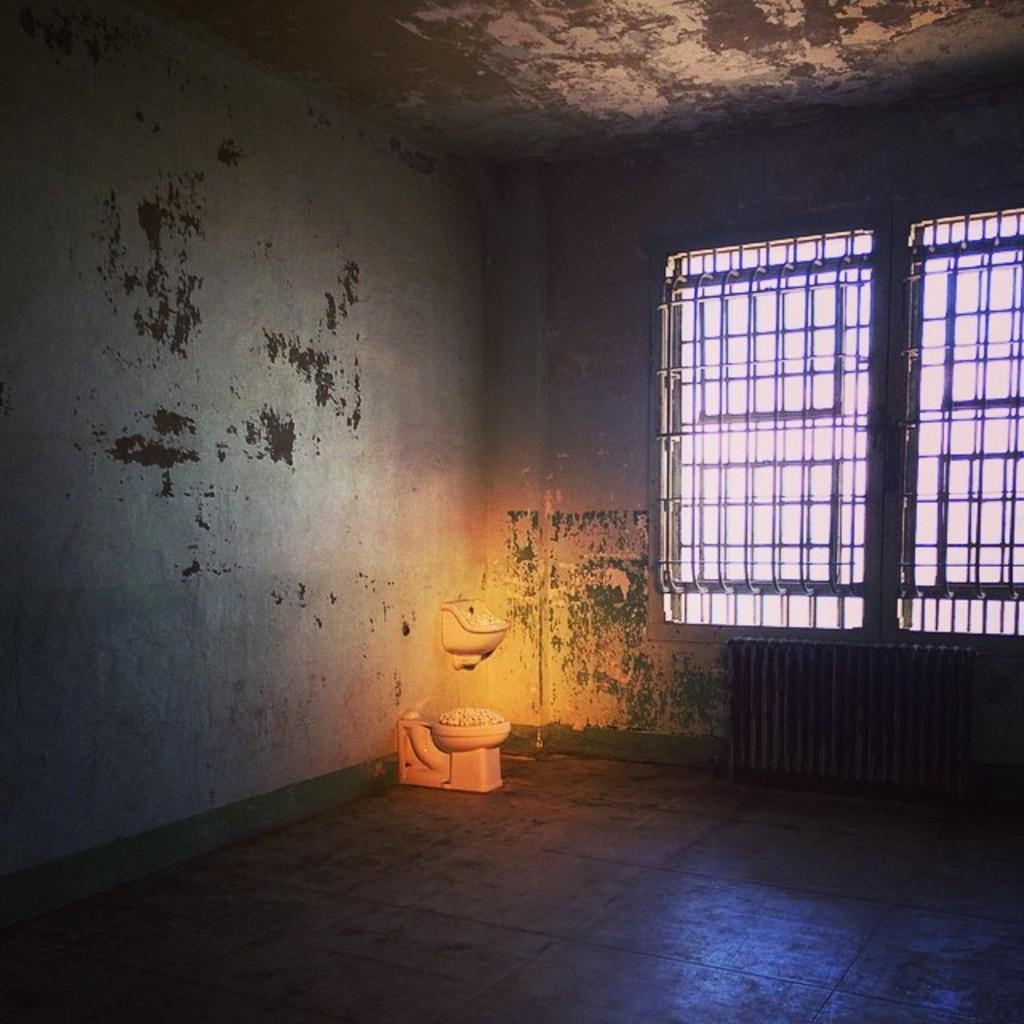Describe this image in one or two sentences. This is an inside view of a room. On the right side there is a window to the wall. There is a toilet placed on the floor. On the left side, I can see the wall. 